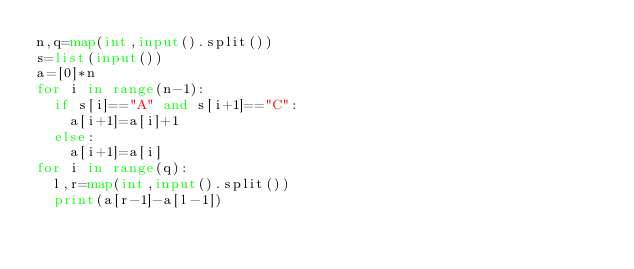Convert code to text. <code><loc_0><loc_0><loc_500><loc_500><_Python_>n,q=map(int,input().split())
s=list(input())
a=[0]*n
for i in range(n-1):
  if s[i]=="A" and s[i+1]=="C":
    a[i+1]=a[i]+1
  else:
    a[i+1]=a[i]
for i in range(q):
  l,r=map(int,input().split())
  print(a[r-1]-a[l-1])</code> 